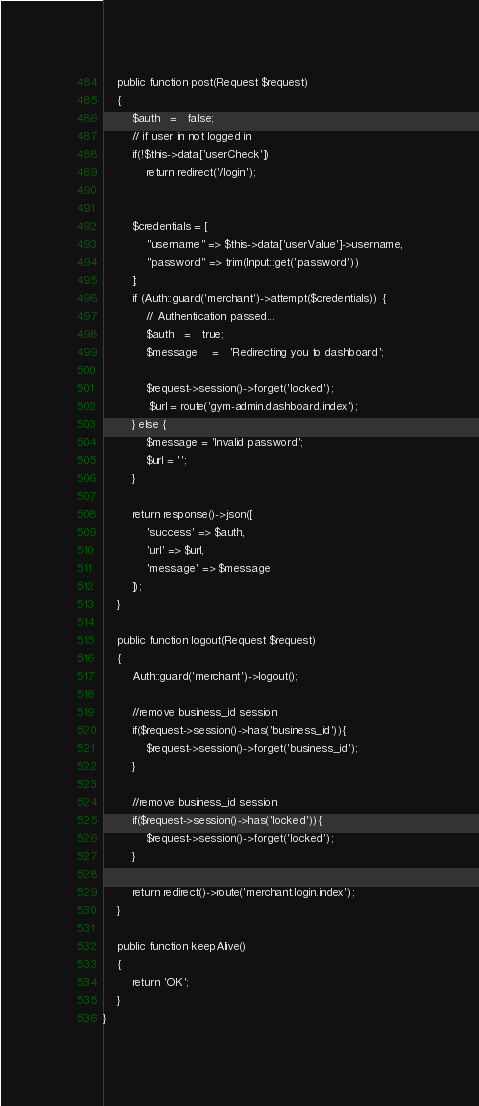<code> <loc_0><loc_0><loc_500><loc_500><_PHP_>    public function post(Request $request)
    {
        $auth	=	false;
        // if user in not logged in
        if(!$this->data['userCheck'])
            return redirect('/login');


        $credentials = [
            "username" => $this->data['userValue']->username,
            "password" => trim(Input::get('password'))
        ];
        if (Auth::guard('merchant')->attempt($credentials)) {
            // Authentication passed...
            $auth	=	true;
            $message	=	'Redirecting you to dashboard';

            $request->session()->forget('locked');
             $url = route('gym-admin.dashboard.index');
        } else {
            $message = 'Invalid password';
            $url = '';
        }

        return response()->json([
            'success' => $auth,
            'url' => $url,
            'message' => $message
        ]);
    }

    public function logout(Request $request)
    {
        Auth::guard('merchant')->logout();

        //remove business_id session
        if($request->session()->has('business_id')){
            $request->session()->forget('business_id');
        }

        //remove business_id session
        if($request->session()->has('locked')){
            $request->session()->forget('locked');
        }

        return redirect()->route('merchant.login.index');
    }

    public function keepAlive()
    {
        return 'OK';
    }
}
</code> 